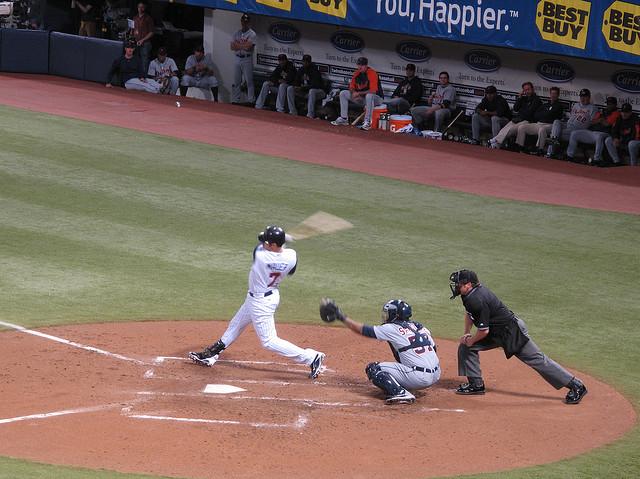What company is on the banner in the background?
Concise answer only. Best buy. Did the catcher catch the ball?
Give a very brief answer. Yes. Did the player hit the ball?
Give a very brief answer. Yes. Are they golfing?
Be succinct. No. What number is the player that is at bat?
Answer briefly. 7. Is the player hesitating?
Write a very short answer. No. Which bank is being advertised?
Answer briefly. None. What is the brand sponsor in the background?
Keep it brief. Best buy. 